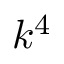Convert formula to latex. <formula><loc_0><loc_0><loc_500><loc_500>k ^ { 4 }</formula> 